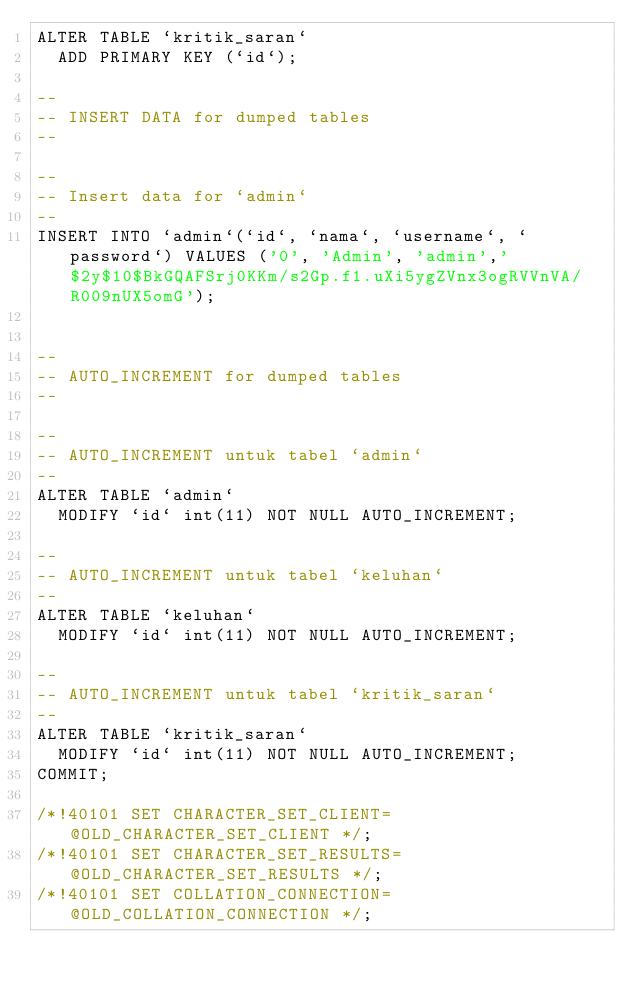Convert code to text. <code><loc_0><loc_0><loc_500><loc_500><_SQL_>ALTER TABLE `kritik_saran`
  ADD PRIMARY KEY (`id`);

--
-- INSERT DATA for dumped tables
--

--
-- Insert data for `admin`
--
INSERT INTO `admin`(`id`, `nama`, `username`, `password`) VALUES ('0', 'Admin', 'admin','$2y$10$BkGQAFSrj0KKm/s2Gp.f1.uXi5ygZVnx3ogRVVnVA/R009nUX5omG');


--
-- AUTO_INCREMENT for dumped tables
--

--
-- AUTO_INCREMENT untuk tabel `admin`
--
ALTER TABLE `admin`
  MODIFY `id` int(11) NOT NULL AUTO_INCREMENT;

--
-- AUTO_INCREMENT untuk tabel `keluhan`
--
ALTER TABLE `keluhan`
  MODIFY `id` int(11) NOT NULL AUTO_INCREMENT;

--
-- AUTO_INCREMENT untuk tabel `kritik_saran`
--
ALTER TABLE `kritik_saran`
  MODIFY `id` int(11) NOT NULL AUTO_INCREMENT;
COMMIT;

/*!40101 SET CHARACTER_SET_CLIENT=@OLD_CHARACTER_SET_CLIENT */;
/*!40101 SET CHARACTER_SET_RESULTS=@OLD_CHARACTER_SET_RESULTS */;
/*!40101 SET COLLATION_CONNECTION=@OLD_COLLATION_CONNECTION */;
</code> 